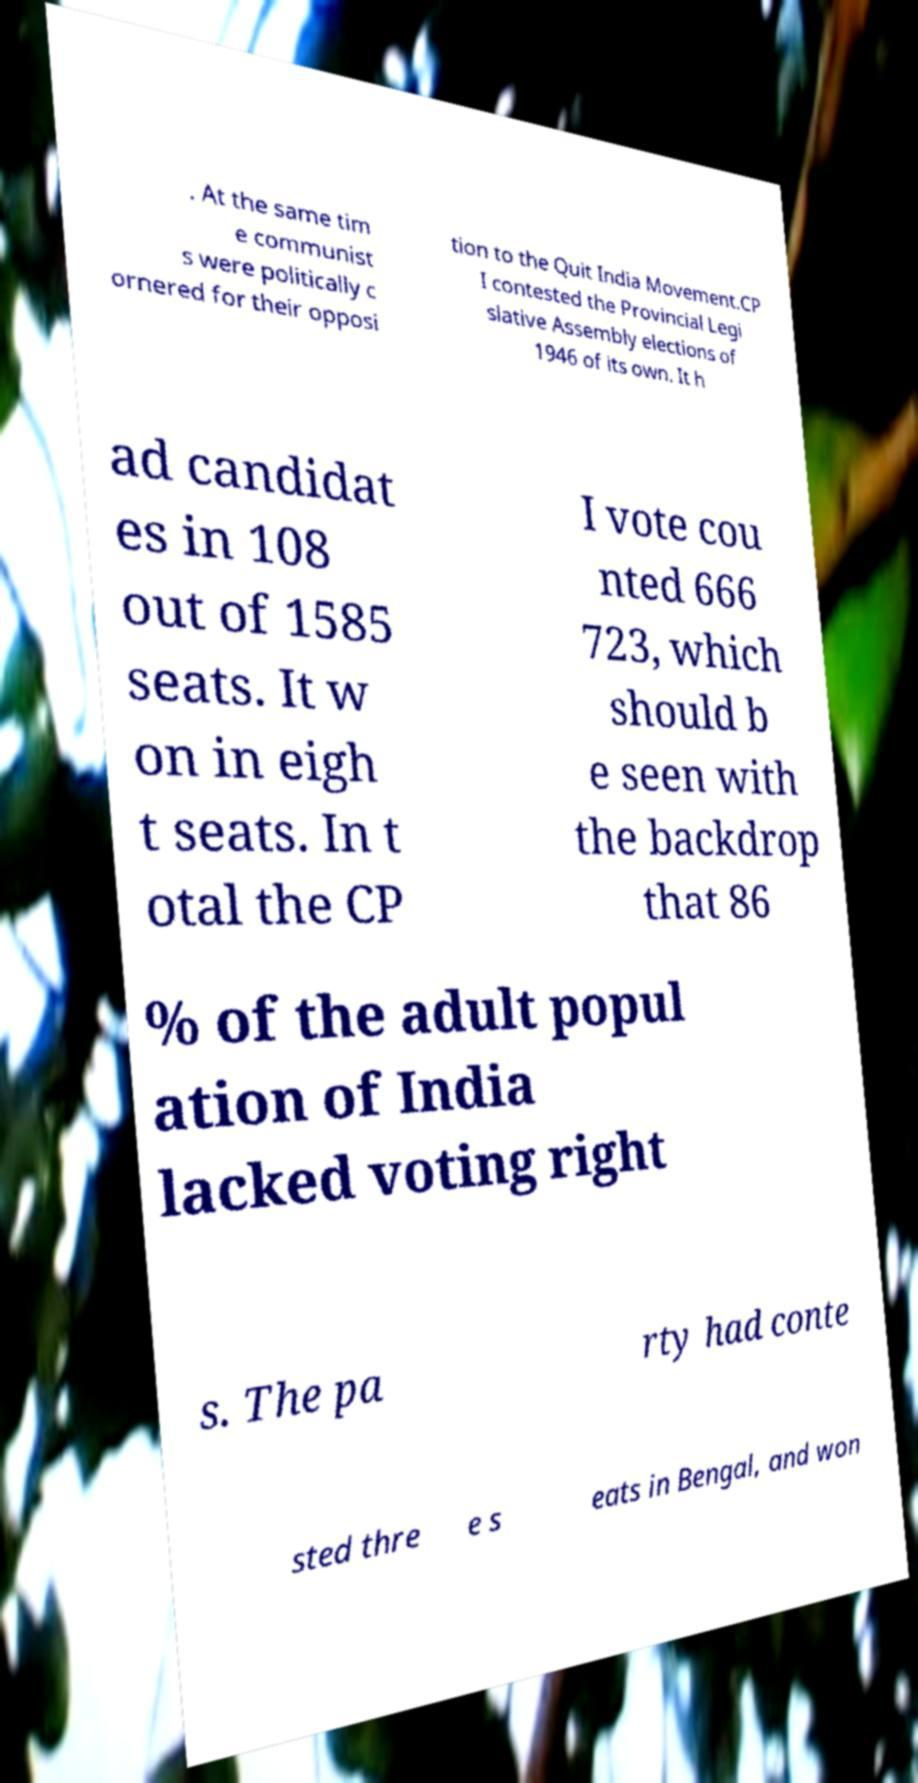What messages or text are displayed in this image? I need them in a readable, typed format. . At the same tim e communist s were politically c ornered for their opposi tion to the Quit India Movement.CP I contested the Provincial Legi slative Assembly elections of 1946 of its own. It h ad candidat es in 108 out of 1585 seats. It w on in eigh t seats. In t otal the CP I vote cou nted 666 723, which should b e seen with the backdrop that 86 % of the adult popul ation of India lacked voting right s. The pa rty had conte sted thre e s eats in Bengal, and won 